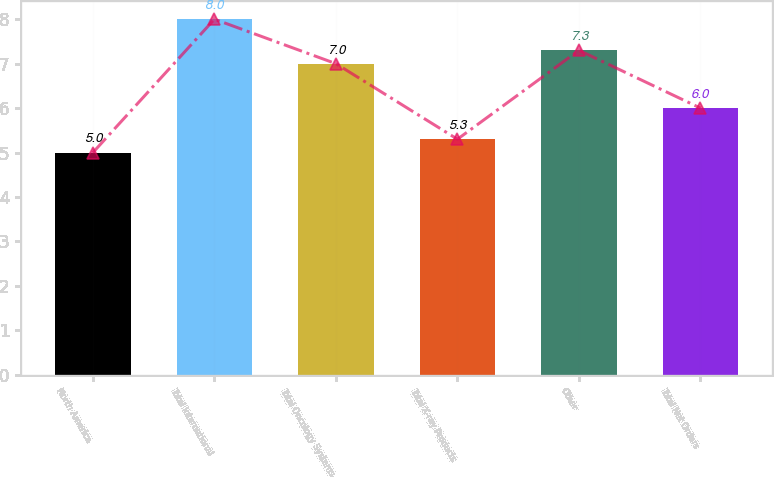Convert chart to OTSL. <chart><loc_0><loc_0><loc_500><loc_500><bar_chart><fcel>North America<fcel>Total International<fcel>Total Oncology Systems<fcel>Total X-ray Products<fcel>Other<fcel>Total Net Orders<nl><fcel>5<fcel>8<fcel>7<fcel>5.3<fcel>7.3<fcel>6<nl></chart> 